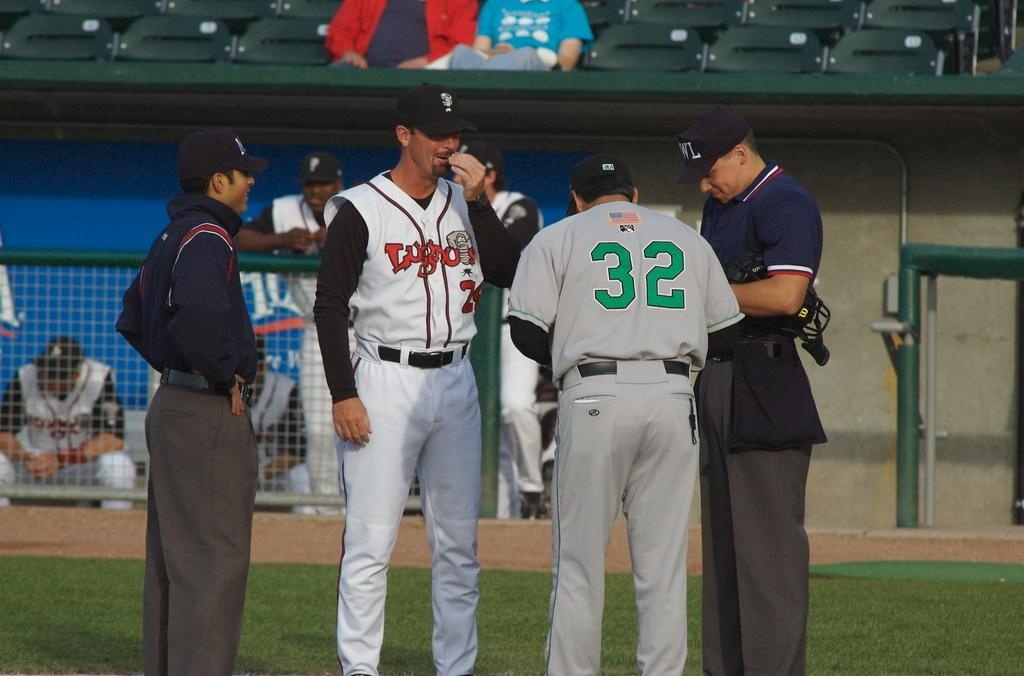<image>
Provide a brief description of the given image. A group of people grouped in a baseball field with one man wearing a shirt that says 32 on the back 